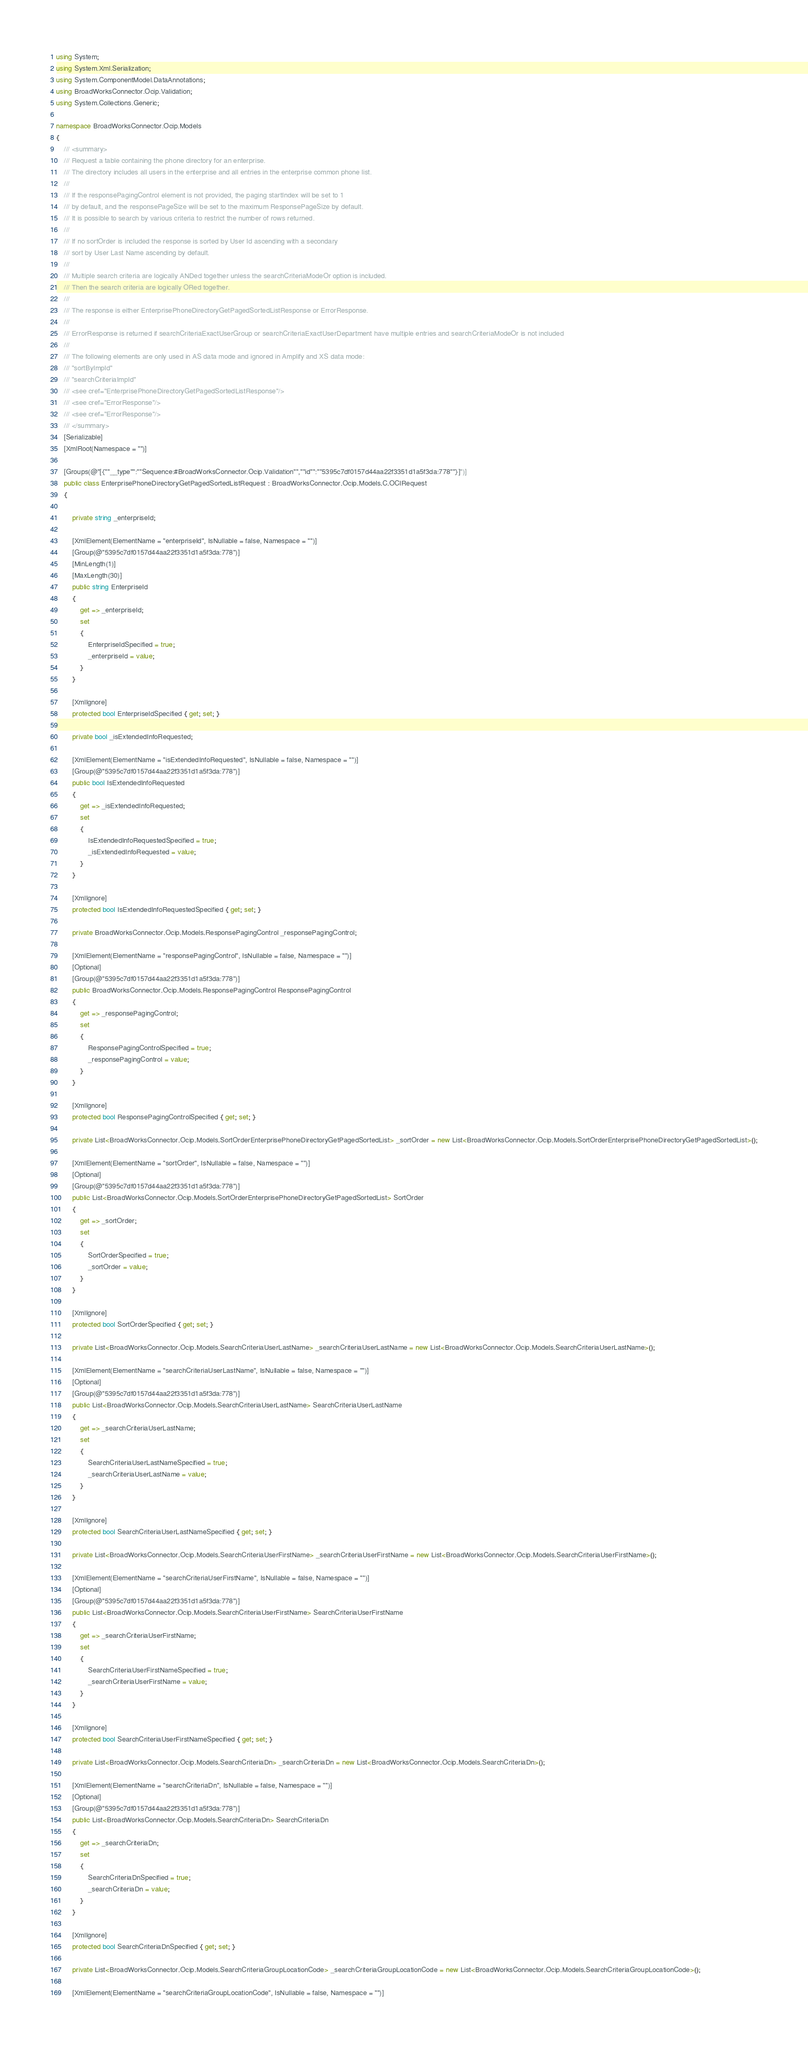<code> <loc_0><loc_0><loc_500><loc_500><_C#_>using System;
using System.Xml.Serialization;
using System.ComponentModel.DataAnnotations;
using BroadWorksConnector.Ocip.Validation;
using System.Collections.Generic;

namespace BroadWorksConnector.Ocip.Models
{
    /// <summary>
    /// Request a table containing the phone directory for an enterprise.
    /// The directory includes all users in the enterprise and all entries in the enterprise common phone list.
    /// 
    /// If the responsePagingControl element is not provided, the paging startIndex will be set to 1
    /// by default, and the responsePageSize will be set to the maximum ResponsePageSize by default.
    /// It is possible to search by various criteria to restrict the number of rows returned.
    /// 
    /// If no sortOrder is included the response is sorted by User Id ascending with a secondary
    /// sort by User Last Name ascending by default.
    /// 
    /// Multiple search criteria are logically ANDed together unless the searchCriteriaModeOr option is included.
    /// Then the search criteria are logically ORed together.
    /// 
    /// The response is either EnterprisePhoneDirectoryGetPagedSortedListResponse or ErrorResponse.
    /// 
    /// ErrorResponse is returned if searchCriteriaExactUserGroup or searchCriteriaExactUserDepartment have multiple entries and searchCriteriaModeOr is not included
    /// 
    /// The following elements are only used in AS data mode and ignored in Amplify and XS data mode:
    /// "sortByImpId"
    /// "searchCriteriaImpId"
    /// <see cref="EnterprisePhoneDirectoryGetPagedSortedListResponse"/>
    /// <see cref="ErrorResponse"/>
    /// <see cref="ErrorResponse"/>
    /// </summary>
    [Serializable]
    [XmlRoot(Namespace = "")]

    [Groups(@"[{""__type"":""Sequence:#BroadWorksConnector.Ocip.Validation"",""id"":""5395c7df0157d44aa22f3351d1a5f3da:778""}]")]
    public class EnterprisePhoneDirectoryGetPagedSortedListRequest : BroadWorksConnector.Ocip.Models.C.OCIRequest
    {

        private string _enterpriseId;

        [XmlElement(ElementName = "enterpriseId", IsNullable = false, Namespace = "")]
        [Group(@"5395c7df0157d44aa22f3351d1a5f3da:778")]
        [MinLength(1)]
        [MaxLength(30)]
        public string EnterpriseId
        {
            get => _enterpriseId;
            set
            {
                EnterpriseIdSpecified = true;
                _enterpriseId = value;
            }
        }

        [XmlIgnore]
        protected bool EnterpriseIdSpecified { get; set; }

        private bool _isExtendedInfoRequested;

        [XmlElement(ElementName = "isExtendedInfoRequested", IsNullable = false, Namespace = "")]
        [Group(@"5395c7df0157d44aa22f3351d1a5f3da:778")]
        public bool IsExtendedInfoRequested
        {
            get => _isExtendedInfoRequested;
            set
            {
                IsExtendedInfoRequestedSpecified = true;
                _isExtendedInfoRequested = value;
            }
        }

        [XmlIgnore]
        protected bool IsExtendedInfoRequestedSpecified { get; set; }

        private BroadWorksConnector.Ocip.Models.ResponsePagingControl _responsePagingControl;

        [XmlElement(ElementName = "responsePagingControl", IsNullable = false, Namespace = "")]
        [Optional]
        [Group(@"5395c7df0157d44aa22f3351d1a5f3da:778")]
        public BroadWorksConnector.Ocip.Models.ResponsePagingControl ResponsePagingControl
        {
            get => _responsePagingControl;
            set
            {
                ResponsePagingControlSpecified = true;
                _responsePagingControl = value;
            }
        }

        [XmlIgnore]
        protected bool ResponsePagingControlSpecified { get; set; }

        private List<BroadWorksConnector.Ocip.Models.SortOrderEnterprisePhoneDirectoryGetPagedSortedList> _sortOrder = new List<BroadWorksConnector.Ocip.Models.SortOrderEnterprisePhoneDirectoryGetPagedSortedList>();

        [XmlElement(ElementName = "sortOrder", IsNullable = false, Namespace = "")]
        [Optional]
        [Group(@"5395c7df0157d44aa22f3351d1a5f3da:778")]
        public List<BroadWorksConnector.Ocip.Models.SortOrderEnterprisePhoneDirectoryGetPagedSortedList> SortOrder
        {
            get => _sortOrder;
            set
            {
                SortOrderSpecified = true;
                _sortOrder = value;
            }
        }

        [XmlIgnore]
        protected bool SortOrderSpecified { get; set; }

        private List<BroadWorksConnector.Ocip.Models.SearchCriteriaUserLastName> _searchCriteriaUserLastName = new List<BroadWorksConnector.Ocip.Models.SearchCriteriaUserLastName>();

        [XmlElement(ElementName = "searchCriteriaUserLastName", IsNullable = false, Namespace = "")]
        [Optional]
        [Group(@"5395c7df0157d44aa22f3351d1a5f3da:778")]
        public List<BroadWorksConnector.Ocip.Models.SearchCriteriaUserLastName> SearchCriteriaUserLastName
        {
            get => _searchCriteriaUserLastName;
            set
            {
                SearchCriteriaUserLastNameSpecified = true;
                _searchCriteriaUserLastName = value;
            }
        }

        [XmlIgnore]
        protected bool SearchCriteriaUserLastNameSpecified { get; set; }

        private List<BroadWorksConnector.Ocip.Models.SearchCriteriaUserFirstName> _searchCriteriaUserFirstName = new List<BroadWorksConnector.Ocip.Models.SearchCriteriaUserFirstName>();

        [XmlElement(ElementName = "searchCriteriaUserFirstName", IsNullable = false, Namespace = "")]
        [Optional]
        [Group(@"5395c7df0157d44aa22f3351d1a5f3da:778")]
        public List<BroadWorksConnector.Ocip.Models.SearchCriteriaUserFirstName> SearchCriteriaUserFirstName
        {
            get => _searchCriteriaUserFirstName;
            set
            {
                SearchCriteriaUserFirstNameSpecified = true;
                _searchCriteriaUserFirstName = value;
            }
        }

        [XmlIgnore]
        protected bool SearchCriteriaUserFirstNameSpecified { get; set; }

        private List<BroadWorksConnector.Ocip.Models.SearchCriteriaDn> _searchCriteriaDn = new List<BroadWorksConnector.Ocip.Models.SearchCriteriaDn>();

        [XmlElement(ElementName = "searchCriteriaDn", IsNullable = false, Namespace = "")]
        [Optional]
        [Group(@"5395c7df0157d44aa22f3351d1a5f3da:778")]
        public List<BroadWorksConnector.Ocip.Models.SearchCriteriaDn> SearchCriteriaDn
        {
            get => _searchCriteriaDn;
            set
            {
                SearchCriteriaDnSpecified = true;
                _searchCriteriaDn = value;
            }
        }

        [XmlIgnore]
        protected bool SearchCriteriaDnSpecified { get; set; }

        private List<BroadWorksConnector.Ocip.Models.SearchCriteriaGroupLocationCode> _searchCriteriaGroupLocationCode = new List<BroadWorksConnector.Ocip.Models.SearchCriteriaGroupLocationCode>();

        [XmlElement(ElementName = "searchCriteriaGroupLocationCode", IsNullable = false, Namespace = "")]</code> 